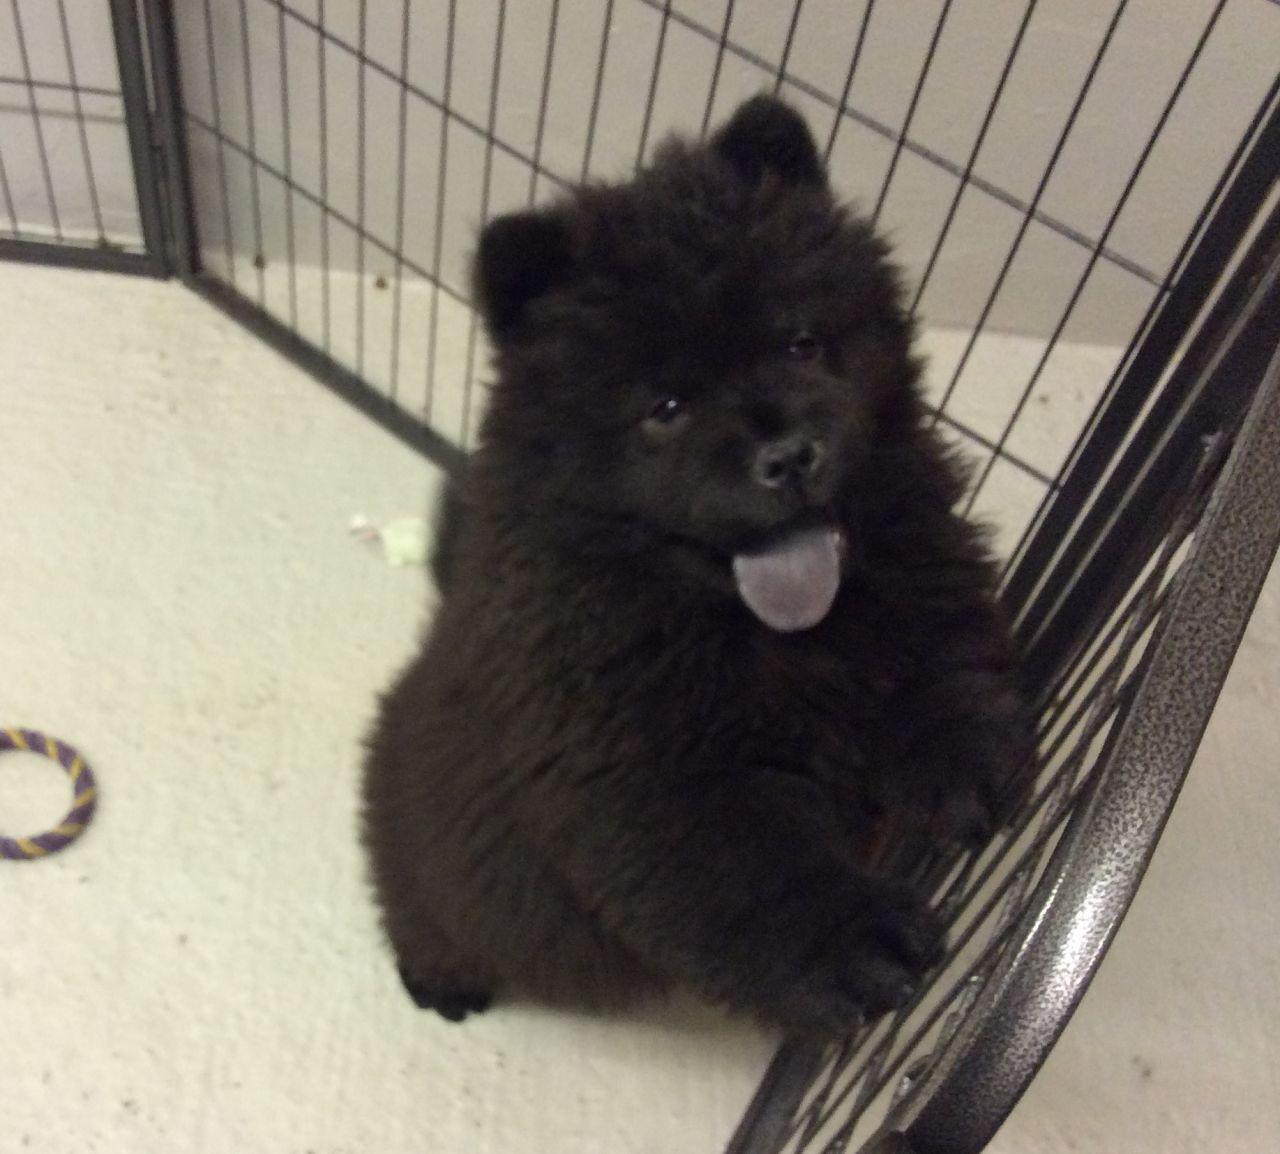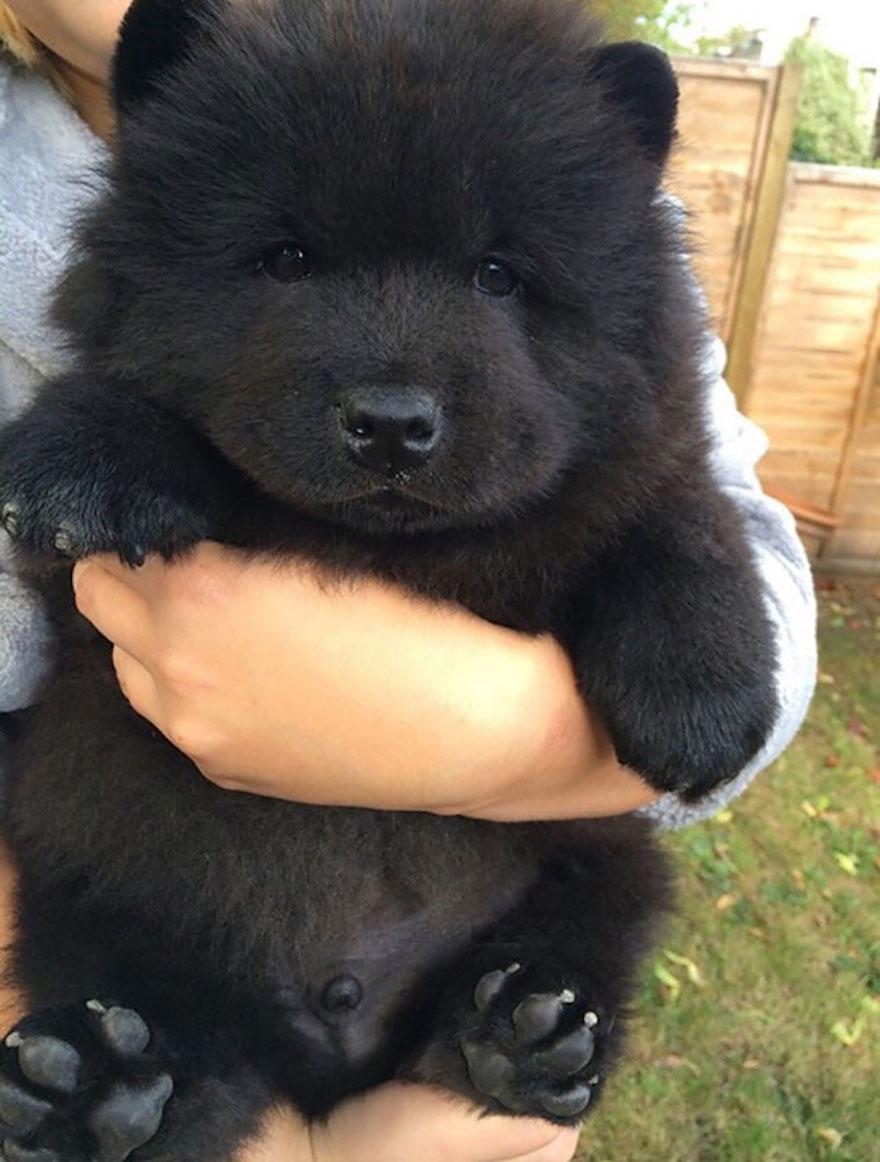The first image is the image on the left, the second image is the image on the right. Assess this claim about the two images: "An image shows rectangular wire 'mesh' behind one black chow dog.". Correct or not? Answer yes or no. Yes. The first image is the image on the left, the second image is the image on the right. For the images shown, is this caption "There are only two dogs and no humans." true? Answer yes or no. No. 